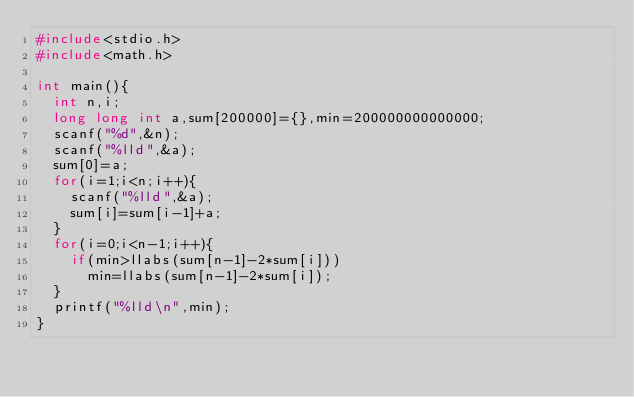Convert code to text. <code><loc_0><loc_0><loc_500><loc_500><_C_>#include<stdio.h>
#include<math.h>

int main(){
  int n,i;
  long long int a,sum[200000]={},min=200000000000000;
  scanf("%d",&n);
  scanf("%lld",&a);
  sum[0]=a;
  for(i=1;i<n;i++){
    scanf("%lld",&a);
    sum[i]=sum[i-1]+a;
  }
  for(i=0;i<n-1;i++){
    if(min>llabs(sum[n-1]-2*sum[i]))
      min=llabs(sum[n-1]-2*sum[i]);
  }
  printf("%lld\n",min);
}</code> 